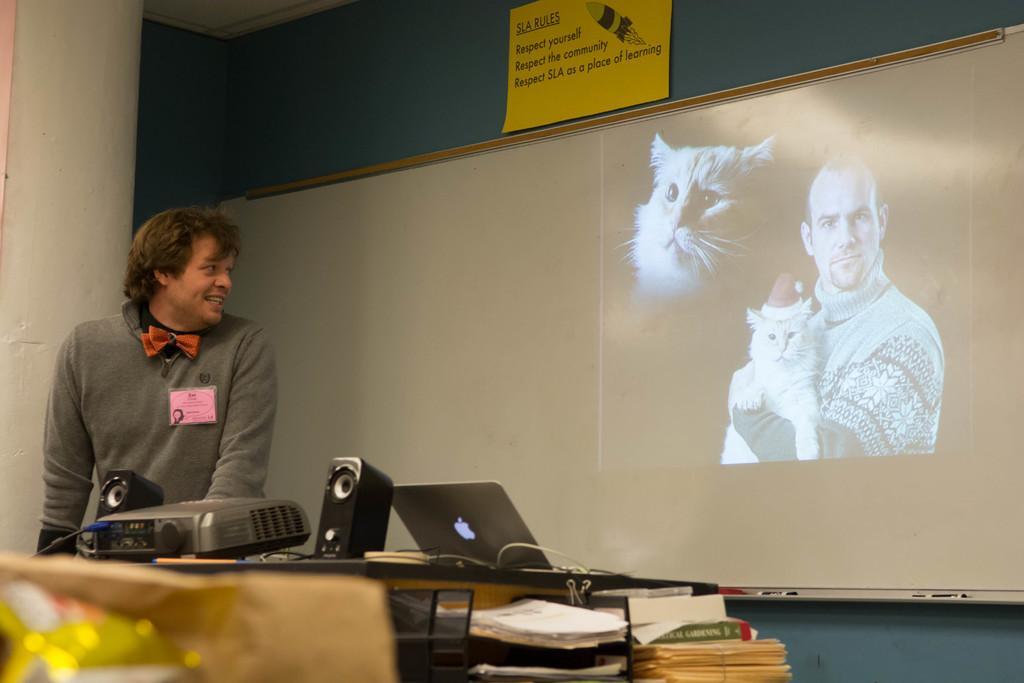Please provide a concise description of this image. In this image we can see a man. He is wearing a grey color T-shirt. At the bottom of the image we can see, papers, book, table, laptop, projector, speaker and one brown color object. There is a big board in the middle of the image. At the top of the image, we can see a yellow color poster on the blue color wall. We can see images of a person and two cats on the board. 